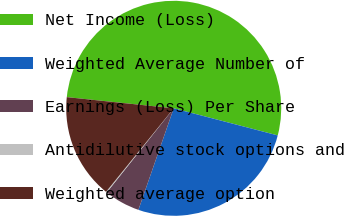Convert chart. <chart><loc_0><loc_0><loc_500><loc_500><pie_chart><fcel>Net Income (Loss)<fcel>Weighted Average Number of<fcel>Earnings (Loss) Per Share<fcel>Antidilutive stock options and<fcel>Weighted average option<nl><fcel>52.4%<fcel>26.27%<fcel>5.37%<fcel>0.14%<fcel>15.82%<nl></chart> 